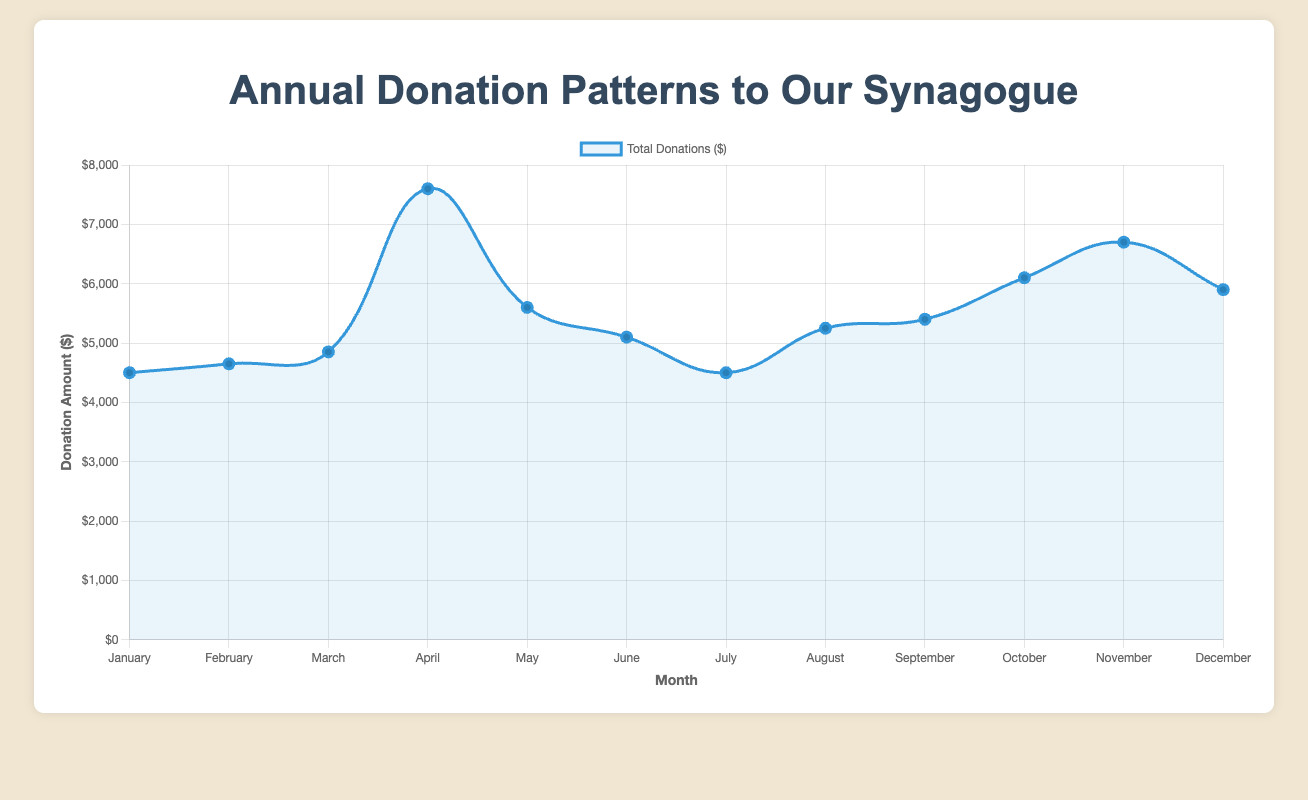Which month had the highest total donations? Observing the peaks in the line plot, April stands out with the highest point on the curve.
Answer: April How much more were the total donations in April compared to January? Comparing the values from the plot, April has $7600 in total donations while January has $4500, so the difference is $7600 - $4500.
Answer: $3100 What is the average total donation amount across all months? Adding up the total donations for each month and dividing by 12 ((4500 + 4650 + 4850 + 7600 + 5600 + 5100 + 4500 + 5250 + 5400 + 6100 + 6700 + 5900) / 12) gives us the average.
Answer: $5483.33 Which month saw the lowest donations, and what was the amount? By identifying the lowest point on the curve, we see that January and July both had $4500 as the lowest donation amounts.
Answer: January and July How do total donations in June compare to those in October? From the curve, June has $5100 compared to October's $6100, so October had higher donations.
Answer: October had higher donations What is the difference in donations between the month with the highest donations and the month with the lowest donations? April has the highest donations with $7600 and January and July have the lowest with $4500, difference is $7600 - $4500.
Answer: $3100 Which months had total donations above $5000? By looking at the curve, the months with donations above $5000 are April, May, August, September, October, and November.
Answer: April, May, August, September, October, November Is there a month in which the total donations are equal to $5900? Observing the curve, December has total donations exactly at $5900.
Answer: December What trends or patterns can be observed in the donation amounts throughout the year? The donations generally increase during religious or significant community periods (April, September, October) and tend to dip in summer months (June, July).
Answer: Seasonal peaks and summer dips 